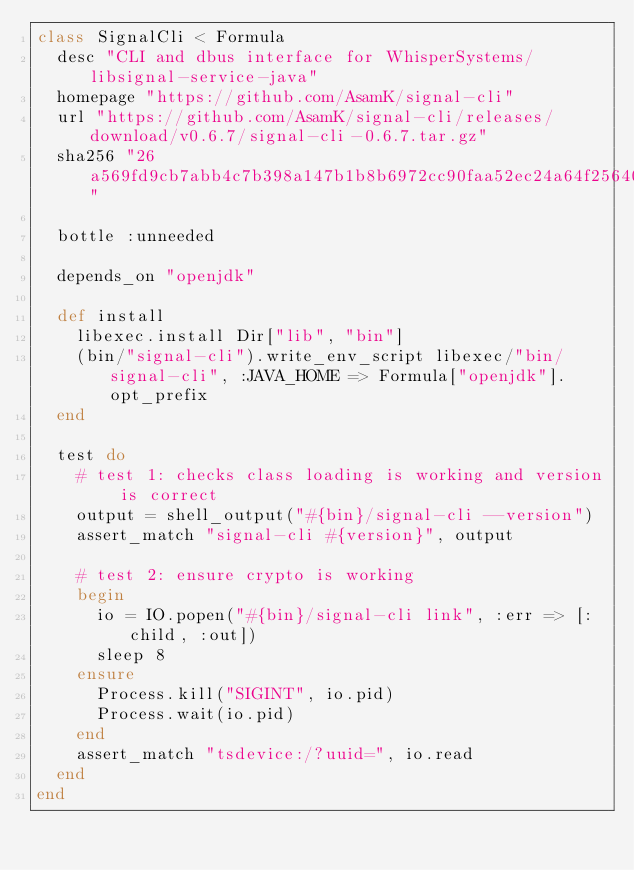<code> <loc_0><loc_0><loc_500><loc_500><_Ruby_>class SignalCli < Formula
  desc "CLI and dbus interface for WhisperSystems/libsignal-service-java"
  homepage "https://github.com/AsamK/signal-cli"
  url "https://github.com/AsamK/signal-cli/releases/download/v0.6.7/signal-cli-0.6.7.tar.gz"
  sha256 "26a569fd9cb7abb4c7b398a147b1b8b6972cc90faa52ec24a64f256401139f8f"

  bottle :unneeded

  depends_on "openjdk"

  def install
    libexec.install Dir["lib", "bin"]
    (bin/"signal-cli").write_env_script libexec/"bin/signal-cli", :JAVA_HOME => Formula["openjdk"].opt_prefix
  end

  test do
    # test 1: checks class loading is working and version is correct
    output = shell_output("#{bin}/signal-cli --version")
    assert_match "signal-cli #{version}", output

    # test 2: ensure crypto is working
    begin
      io = IO.popen("#{bin}/signal-cli link", :err => [:child, :out])
      sleep 8
    ensure
      Process.kill("SIGINT", io.pid)
      Process.wait(io.pid)
    end
    assert_match "tsdevice:/?uuid=", io.read
  end
end
</code> 